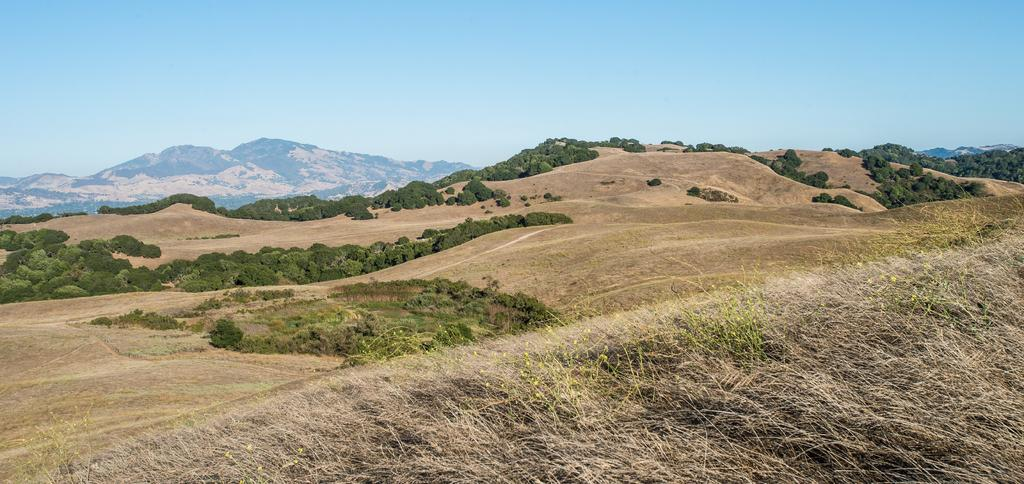What type of natural landscape is depicted in the image? The image features mountains, trees, and grass, which are all elements of a natural landscape. Can you describe the vegetation in the image? There are trees and grass visible in the image. What is visible in the sky in the image? The sky is visible in the image. What type of prose can be seen in the image? There is no prose present in the image, as it is a photograph of a natural landscape. Can you describe the worms crawling on the grass in the image? There are no worms visible in the image; it features mountains, trees, grass, and the sky. 